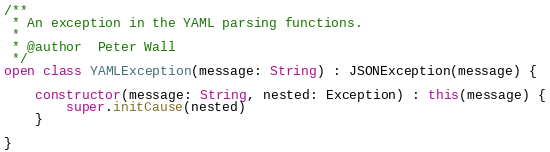Convert code to text. <code><loc_0><loc_0><loc_500><loc_500><_Kotlin_>
/**
 * An exception in the YAML parsing functions.
 *
 * @author  Peter Wall
 */
open class YAMLException(message: String) : JSONException(message) {

    constructor(message: String, nested: Exception) : this(message) {
        super.initCause(nested)
    }

}
</code> 